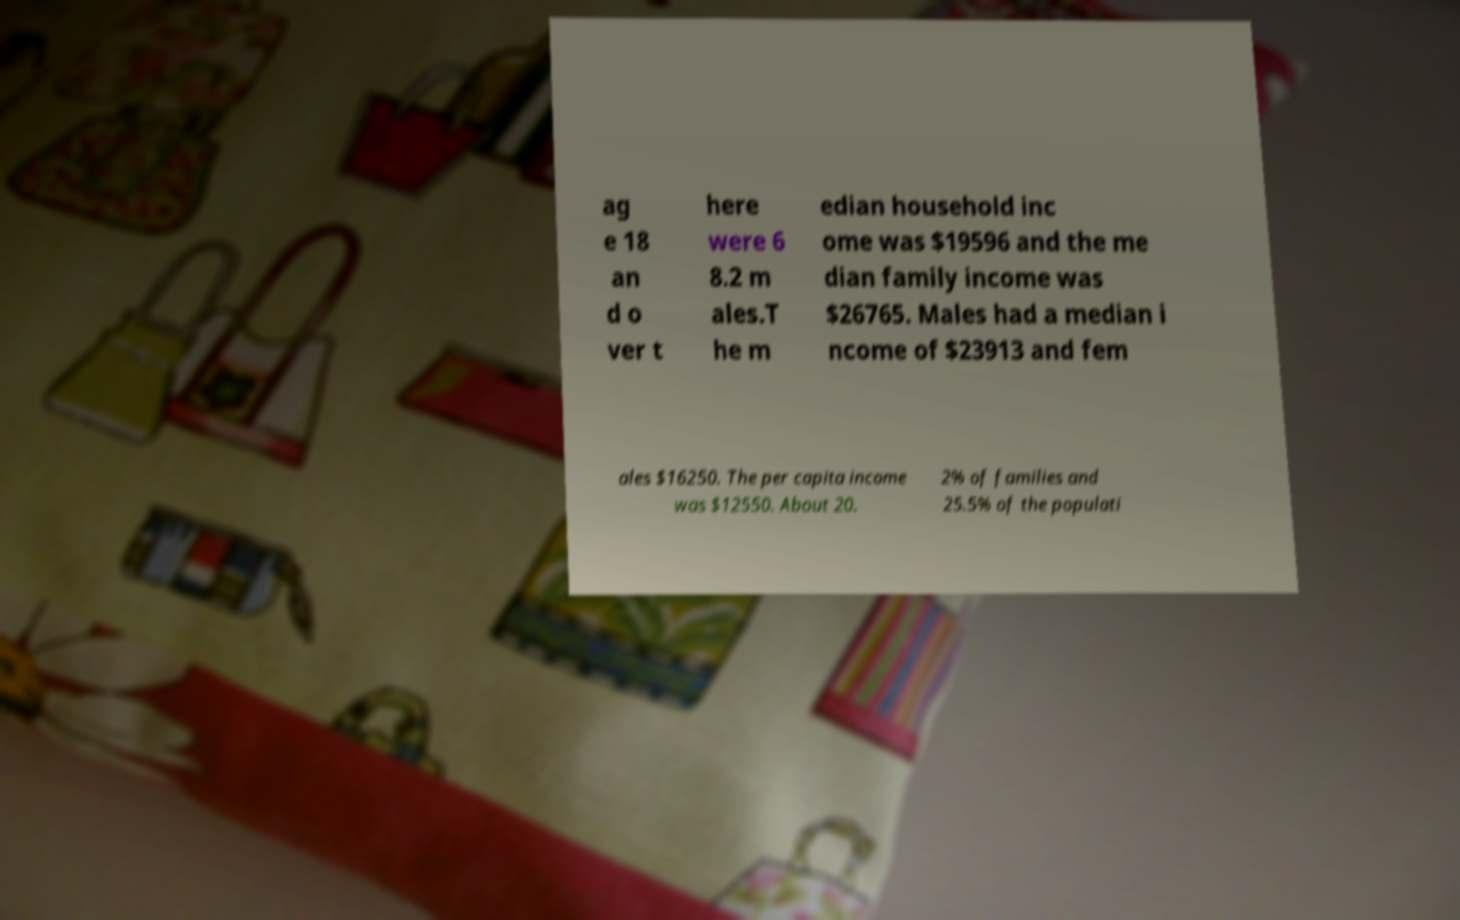Could you assist in decoding the text presented in this image and type it out clearly? ag e 18 an d o ver t here were 6 8.2 m ales.T he m edian household inc ome was $19596 and the me dian family income was $26765. Males had a median i ncome of $23913 and fem ales $16250. The per capita income was $12550. About 20. 2% of families and 25.5% of the populati 